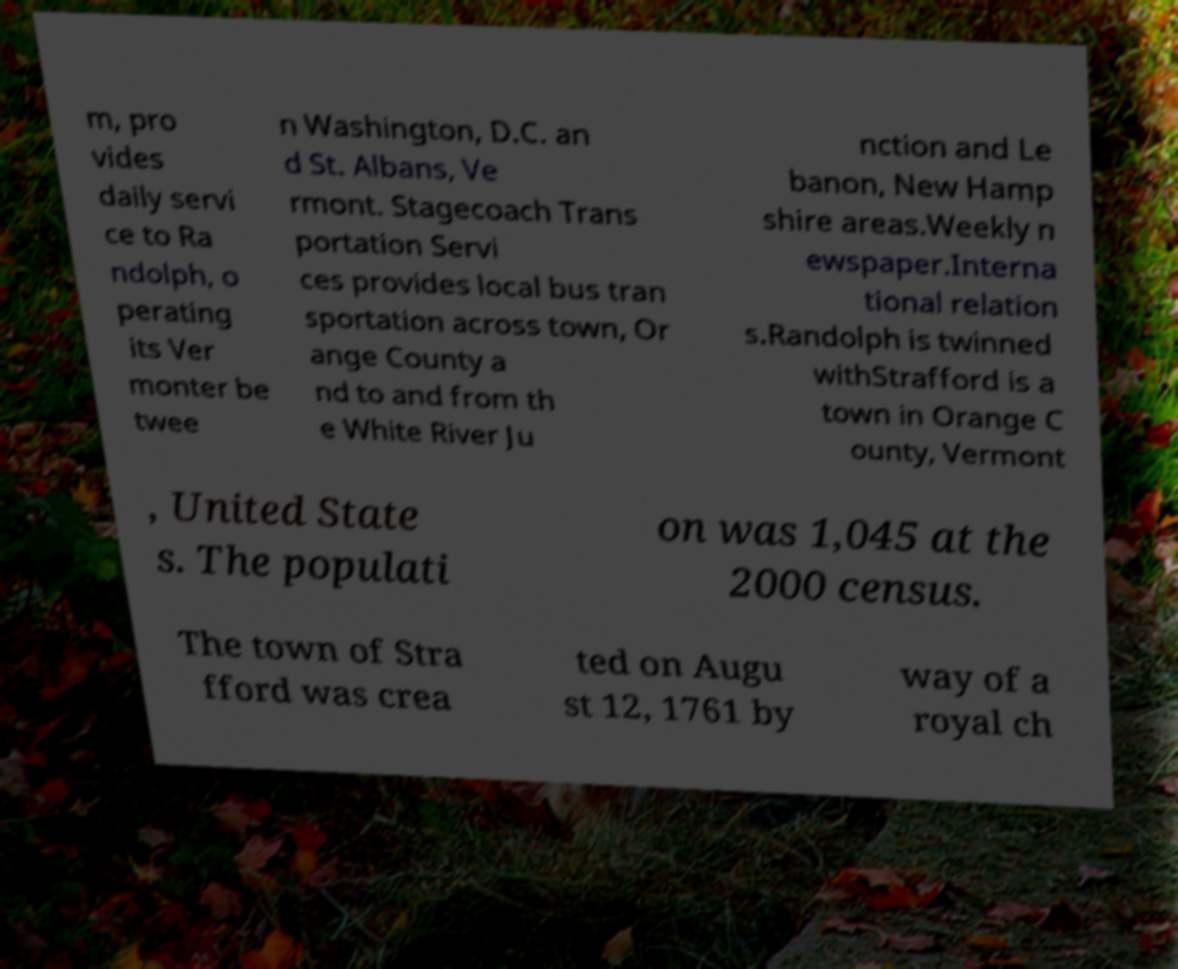Can you read and provide the text displayed in the image?This photo seems to have some interesting text. Can you extract and type it out for me? m, pro vides daily servi ce to Ra ndolph, o perating its Ver monter be twee n Washington, D.C. an d St. Albans, Ve rmont. Stagecoach Trans portation Servi ces provides local bus tran sportation across town, Or ange County a nd to and from th e White River Ju nction and Le banon, New Hamp shire areas.Weekly n ewspaper.Interna tional relation s.Randolph is twinned withStrafford is a town in Orange C ounty, Vermont , United State s. The populati on was 1,045 at the 2000 census. The town of Stra fford was crea ted on Augu st 12, 1761 by way of a royal ch 